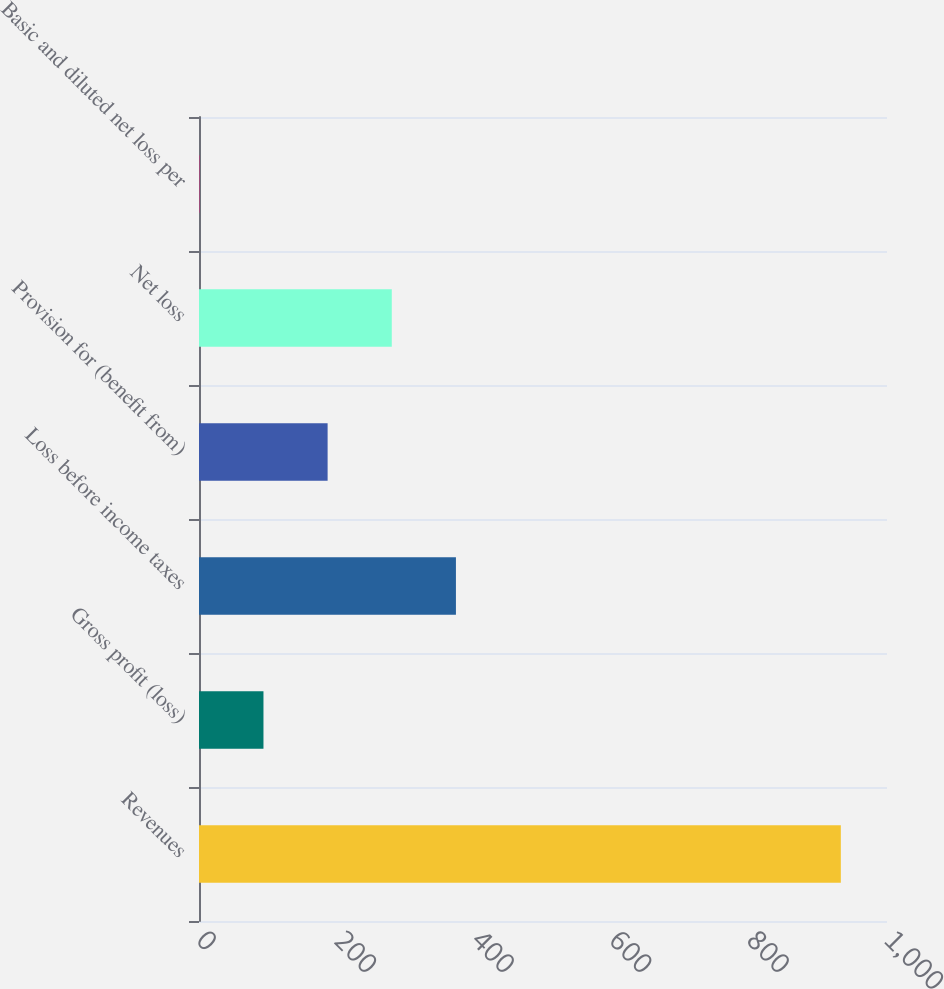<chart> <loc_0><loc_0><loc_500><loc_500><bar_chart><fcel>Revenues<fcel>Gross profit (loss)<fcel>Loss before income taxes<fcel>Provision for (benefit from)<fcel>Net loss<fcel>Basic and diluted net loss per<nl><fcel>932.9<fcel>93.7<fcel>373.44<fcel>186.94<fcel>280.19<fcel>0.45<nl></chart> 